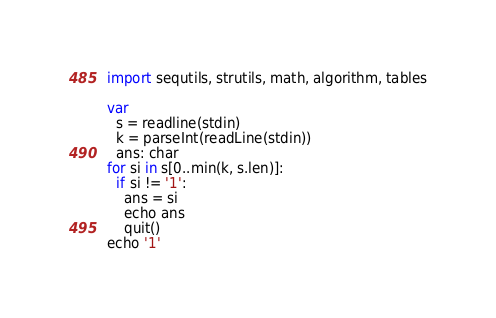Convert code to text. <code><loc_0><loc_0><loc_500><loc_500><_Nim_>import sequtils, strutils, math, algorithm, tables

var
  s = readline(stdin)
  k = parseInt(readLine(stdin))
  ans: char
for si in s[0..min(k, s.len)]:
  if si != '1':
    ans = si
    echo ans
    quit()
echo '1'</code> 